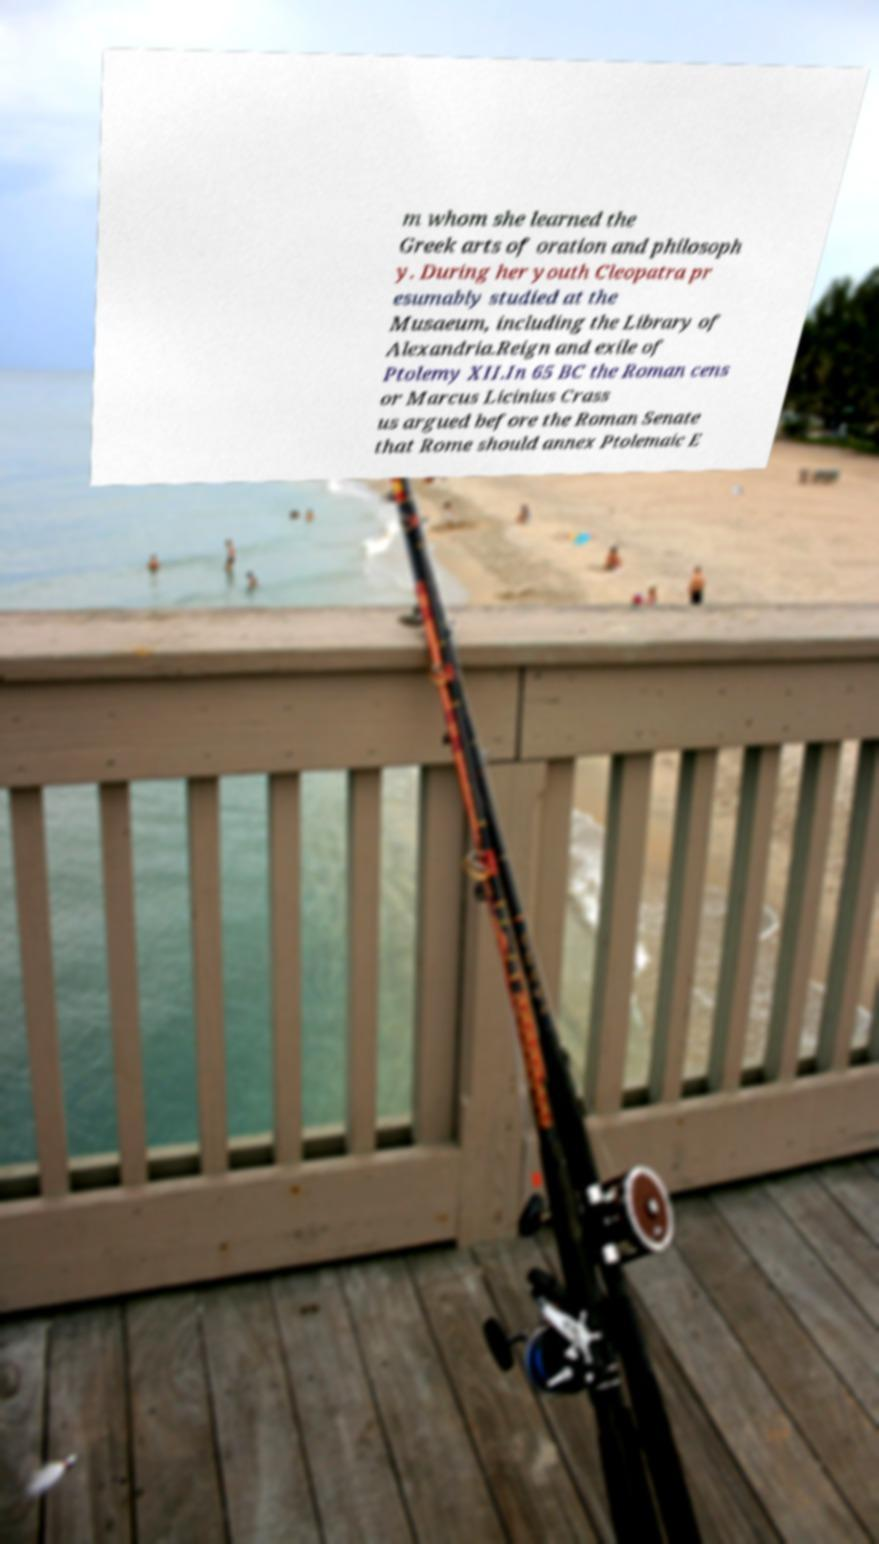What messages or text are displayed in this image? I need them in a readable, typed format. m whom she learned the Greek arts of oration and philosoph y. During her youth Cleopatra pr esumably studied at the Musaeum, including the Library of Alexandria.Reign and exile of Ptolemy XII.In 65 BC the Roman cens or Marcus Licinius Crass us argued before the Roman Senate that Rome should annex Ptolemaic E 